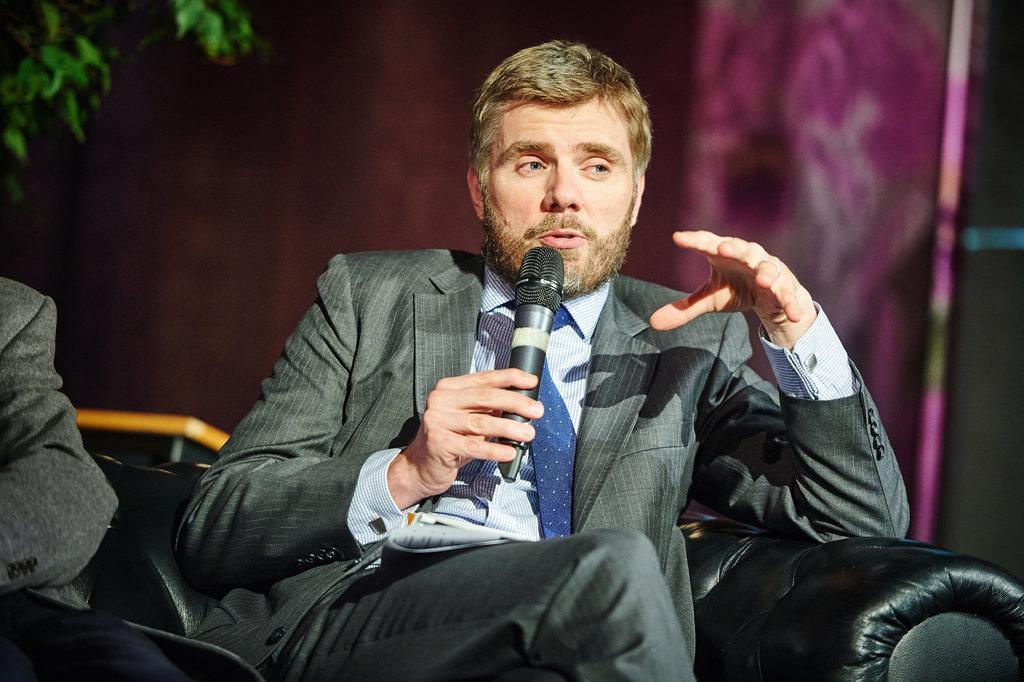In one or two sentences, can you explain what this image depicts? This is a picture of a man sitting on a chair holding a microphone. Background of the man is a wall. 